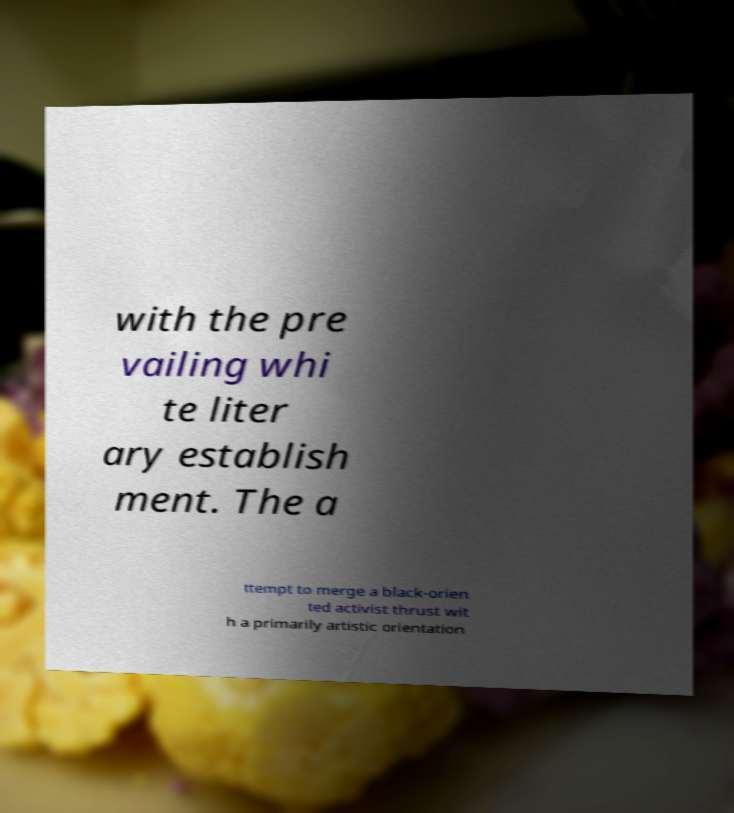I need the written content from this picture converted into text. Can you do that? with the pre vailing whi te liter ary establish ment. The a ttempt to merge a black-orien ted activist thrust wit h a primarily artistic orientation 